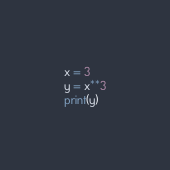<code> <loc_0><loc_0><loc_500><loc_500><_Python_>x = 3
y = x**3
print(y)</code> 